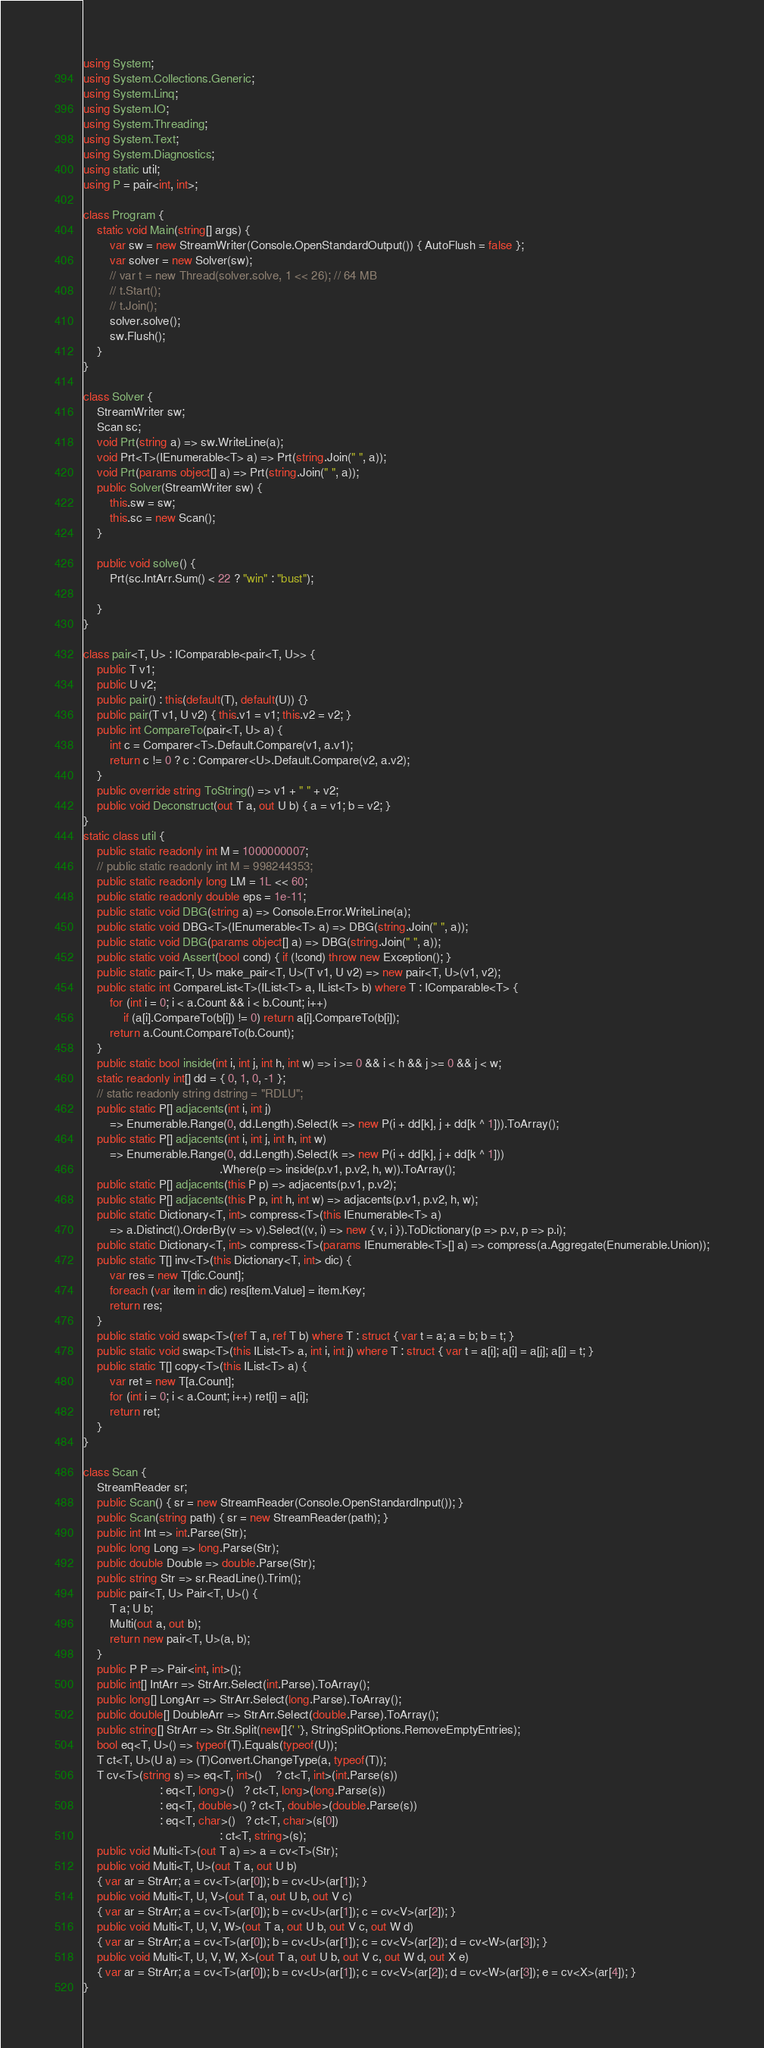Convert code to text. <code><loc_0><loc_0><loc_500><loc_500><_C#_>using System;
using System.Collections.Generic;
using System.Linq;
using System.IO;
using System.Threading;
using System.Text;
using System.Diagnostics;
using static util;
using P = pair<int, int>;

class Program {
    static void Main(string[] args) {
        var sw = new StreamWriter(Console.OpenStandardOutput()) { AutoFlush = false };
        var solver = new Solver(sw);
        // var t = new Thread(solver.solve, 1 << 26); // 64 MB
        // t.Start();
        // t.Join();
        solver.solve();
        sw.Flush();
    }
}

class Solver {
    StreamWriter sw;
    Scan sc;
    void Prt(string a) => sw.WriteLine(a);
    void Prt<T>(IEnumerable<T> a) => Prt(string.Join(" ", a));
    void Prt(params object[] a) => Prt(string.Join(" ", a));
    public Solver(StreamWriter sw) {
        this.sw = sw;
        this.sc = new Scan();
    }

    public void solve() {
        Prt(sc.IntArr.Sum() < 22 ? "win" : "bust");

    }
}

class pair<T, U> : IComparable<pair<T, U>> {
    public T v1;
    public U v2;
    public pair() : this(default(T), default(U)) {}
    public pair(T v1, U v2) { this.v1 = v1; this.v2 = v2; }
    public int CompareTo(pair<T, U> a) {
        int c = Comparer<T>.Default.Compare(v1, a.v1);
        return c != 0 ? c : Comparer<U>.Default.Compare(v2, a.v2);
    }
    public override string ToString() => v1 + " " + v2;
    public void Deconstruct(out T a, out U b) { a = v1; b = v2; }
}
static class util {
    public static readonly int M = 1000000007;
    // public static readonly int M = 998244353;
    public static readonly long LM = 1L << 60;
    public static readonly double eps = 1e-11;
    public static void DBG(string a) => Console.Error.WriteLine(a);
    public static void DBG<T>(IEnumerable<T> a) => DBG(string.Join(" ", a));
    public static void DBG(params object[] a) => DBG(string.Join(" ", a));
    public static void Assert(bool cond) { if (!cond) throw new Exception(); }
    public static pair<T, U> make_pair<T, U>(T v1, U v2) => new pair<T, U>(v1, v2);
    public static int CompareList<T>(IList<T> a, IList<T> b) where T : IComparable<T> {
        for (int i = 0; i < a.Count && i < b.Count; i++)
            if (a[i].CompareTo(b[i]) != 0) return a[i].CompareTo(b[i]);
        return a.Count.CompareTo(b.Count);
    }
    public static bool inside(int i, int j, int h, int w) => i >= 0 && i < h && j >= 0 && j < w;
    static readonly int[] dd = { 0, 1, 0, -1 };
    // static readonly string dstring = "RDLU";
    public static P[] adjacents(int i, int j)
        => Enumerable.Range(0, dd.Length).Select(k => new P(i + dd[k], j + dd[k ^ 1])).ToArray();
    public static P[] adjacents(int i, int j, int h, int w)
        => Enumerable.Range(0, dd.Length).Select(k => new P(i + dd[k], j + dd[k ^ 1]))
                                         .Where(p => inside(p.v1, p.v2, h, w)).ToArray();
    public static P[] adjacents(this P p) => adjacents(p.v1, p.v2);
    public static P[] adjacents(this P p, int h, int w) => adjacents(p.v1, p.v2, h, w);
    public static Dictionary<T, int> compress<T>(this IEnumerable<T> a)
        => a.Distinct().OrderBy(v => v).Select((v, i) => new { v, i }).ToDictionary(p => p.v, p => p.i);
    public static Dictionary<T, int> compress<T>(params IEnumerable<T>[] a) => compress(a.Aggregate(Enumerable.Union));
    public static T[] inv<T>(this Dictionary<T, int> dic) {
        var res = new T[dic.Count];
        foreach (var item in dic) res[item.Value] = item.Key;
        return res;
    }
    public static void swap<T>(ref T a, ref T b) where T : struct { var t = a; a = b; b = t; }
    public static void swap<T>(this IList<T> a, int i, int j) where T : struct { var t = a[i]; a[i] = a[j]; a[j] = t; }
    public static T[] copy<T>(this IList<T> a) {
        var ret = new T[a.Count];
        for (int i = 0; i < a.Count; i++) ret[i] = a[i];
        return ret;
    }
}

class Scan {
    StreamReader sr;
    public Scan() { sr = new StreamReader(Console.OpenStandardInput()); }
    public Scan(string path) { sr = new StreamReader(path); }
    public int Int => int.Parse(Str);
    public long Long => long.Parse(Str);
    public double Double => double.Parse(Str);
    public string Str => sr.ReadLine().Trim();
    public pair<T, U> Pair<T, U>() {
        T a; U b;
        Multi(out a, out b);
        return new pair<T, U>(a, b);
    }
    public P P => Pair<int, int>();
    public int[] IntArr => StrArr.Select(int.Parse).ToArray();
    public long[] LongArr => StrArr.Select(long.Parse).ToArray();
    public double[] DoubleArr => StrArr.Select(double.Parse).ToArray();
    public string[] StrArr => Str.Split(new[]{' '}, StringSplitOptions.RemoveEmptyEntries);
    bool eq<T, U>() => typeof(T).Equals(typeof(U));
    T ct<T, U>(U a) => (T)Convert.ChangeType(a, typeof(T));
    T cv<T>(string s) => eq<T, int>()    ? ct<T, int>(int.Parse(s))
                       : eq<T, long>()   ? ct<T, long>(long.Parse(s))
                       : eq<T, double>() ? ct<T, double>(double.Parse(s))
                       : eq<T, char>()   ? ct<T, char>(s[0])
                                         : ct<T, string>(s);
    public void Multi<T>(out T a) => a = cv<T>(Str);
    public void Multi<T, U>(out T a, out U b)
    { var ar = StrArr; a = cv<T>(ar[0]); b = cv<U>(ar[1]); }
    public void Multi<T, U, V>(out T a, out U b, out V c)
    { var ar = StrArr; a = cv<T>(ar[0]); b = cv<U>(ar[1]); c = cv<V>(ar[2]); }
    public void Multi<T, U, V, W>(out T a, out U b, out V c, out W d)
    { var ar = StrArr; a = cv<T>(ar[0]); b = cv<U>(ar[1]); c = cv<V>(ar[2]); d = cv<W>(ar[3]); }
    public void Multi<T, U, V, W, X>(out T a, out U b, out V c, out W d, out X e)
    { var ar = StrArr; a = cv<T>(ar[0]); b = cv<U>(ar[1]); c = cv<V>(ar[2]); d = cv<W>(ar[3]); e = cv<X>(ar[4]); }
}
</code> 